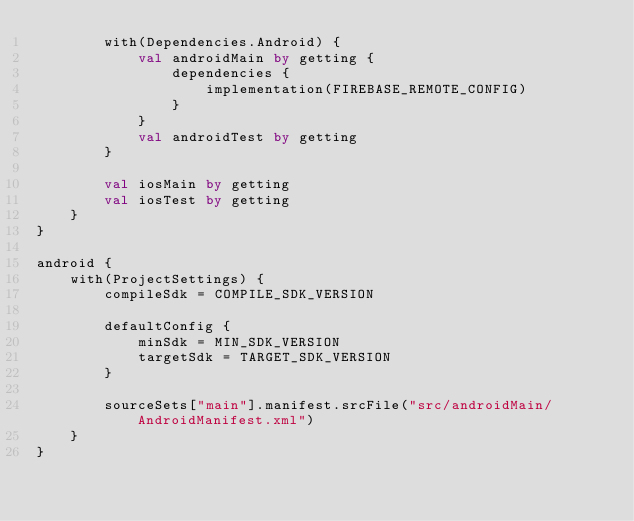Convert code to text. <code><loc_0><loc_0><loc_500><loc_500><_Kotlin_>        with(Dependencies.Android) {
            val androidMain by getting {
                dependencies {
                    implementation(FIREBASE_REMOTE_CONFIG)
                }
            }
            val androidTest by getting
        }

        val iosMain by getting
        val iosTest by getting
    }
}

android {
    with(ProjectSettings) {
        compileSdk = COMPILE_SDK_VERSION

        defaultConfig {
            minSdk = MIN_SDK_VERSION
            targetSdk = TARGET_SDK_VERSION
        }

        sourceSets["main"].manifest.srcFile("src/androidMain/AndroidManifest.xml")
    }
}
</code> 